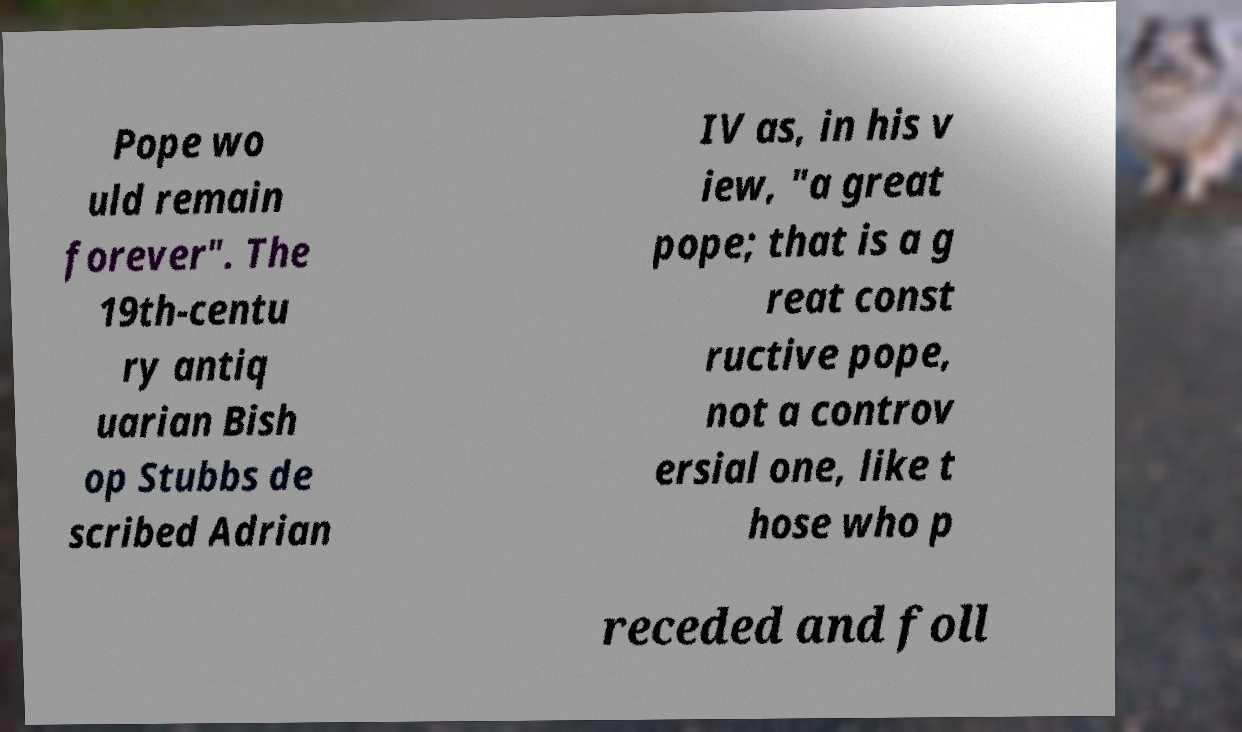What messages or text are displayed in this image? I need them in a readable, typed format. Pope wo uld remain forever". The 19th-centu ry antiq uarian Bish op Stubbs de scribed Adrian IV as, in his v iew, "a great pope; that is a g reat const ructive pope, not a controv ersial one, like t hose who p receded and foll 